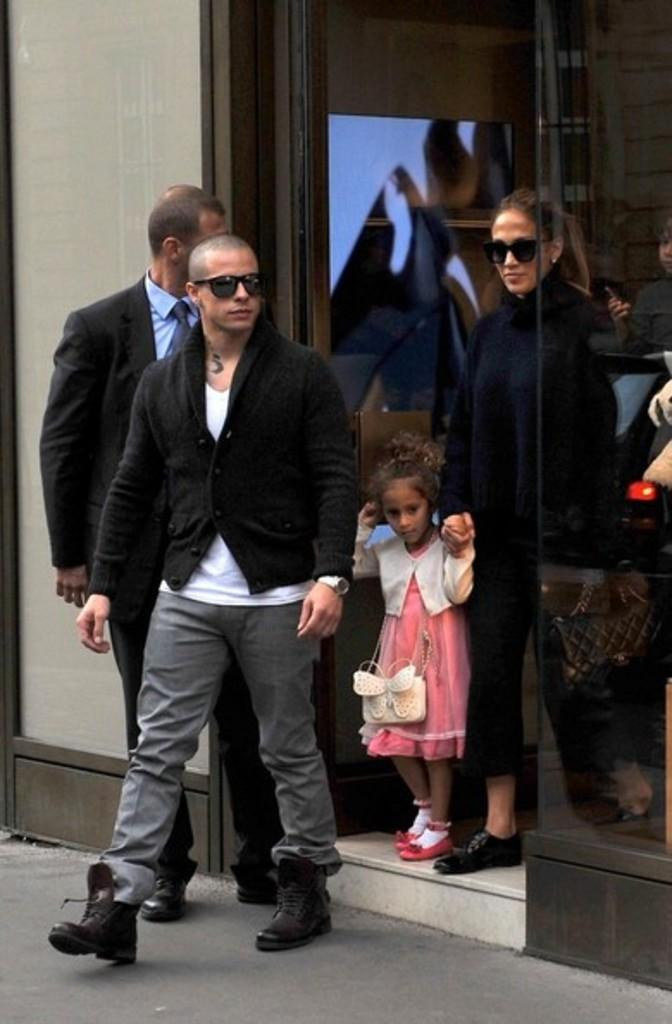Who is the main subject in the image? There is a man in the image. What is the man doing in the image? The man is walking out from a glass door. Are there any other people in the image? Yes, there is a woman and a girl child in the image. What are the woman and the girl child doing in the image? The woman is walking, and the girl child is also walking. What type of poison is being used to expand the glass door in the image? There is no mention of poison or expansion in the image. The glass door is not being altered or affected by any substance. 